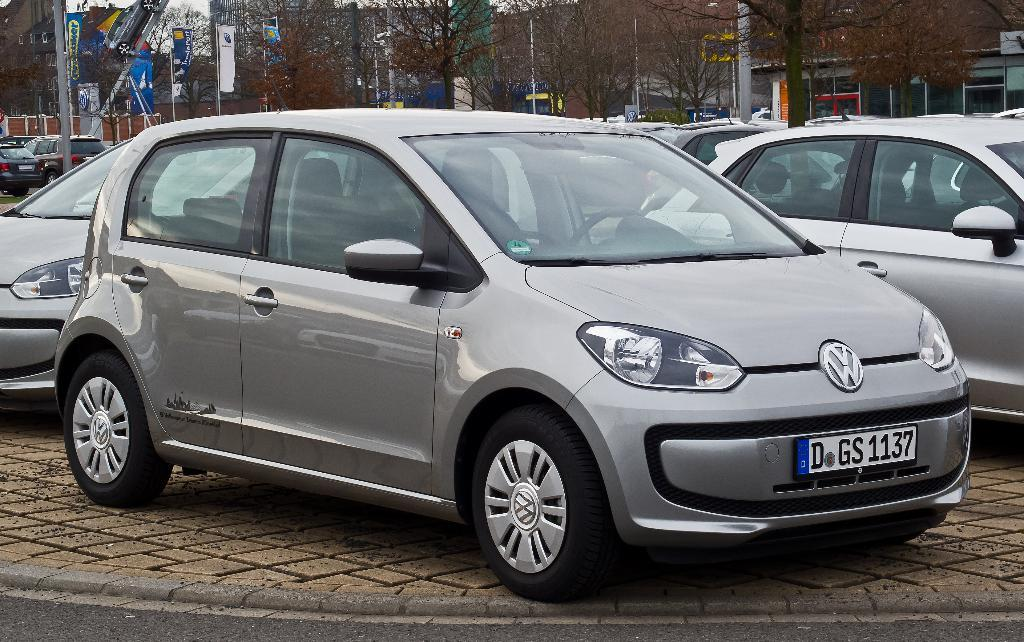What can be seen in the image? There are vehicles in the image. What is present in the background of the image? There are banners attached to poles, trees, and buildings in the background. What is the color of the sky in the image? The sky is white in color. Where is the kitten playing in the scene? There is no kitten present in the image, so it cannot be playing in the scene. 